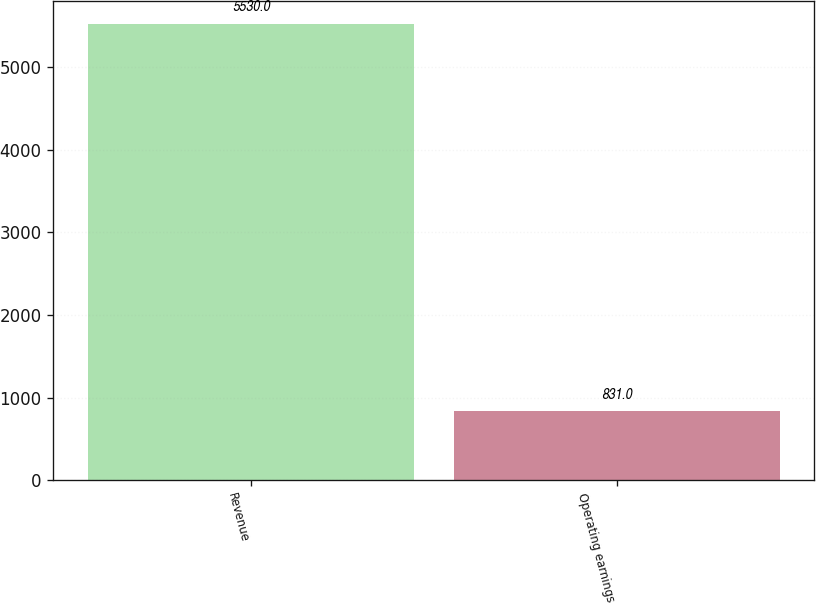<chart> <loc_0><loc_0><loc_500><loc_500><bar_chart><fcel>Revenue<fcel>Operating earnings<nl><fcel>5530<fcel>831<nl></chart> 